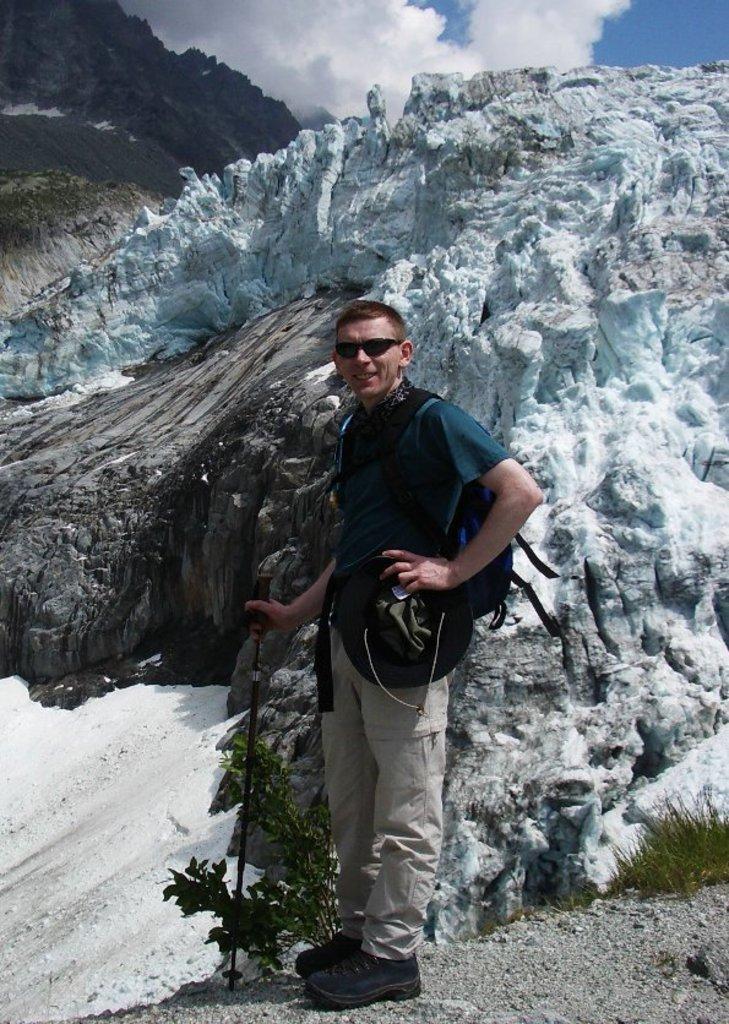How would you summarize this image in a sentence or two? In this image we can see mountains. There are few plants in the image. A person is standing and holding an object in his hand. There is a blue and cloudy sky in the image. 